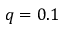Convert formula to latex. <formula><loc_0><loc_0><loc_500><loc_500>q = 0 . 1</formula> 